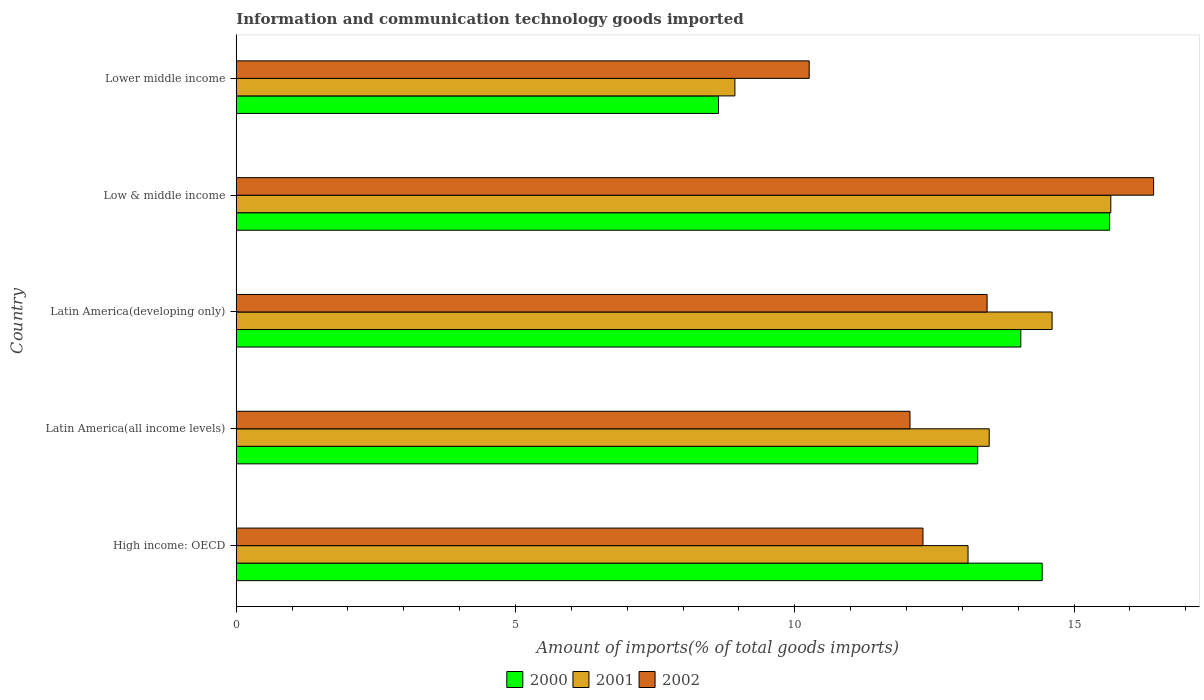How many groups of bars are there?
Ensure brevity in your answer.  5. Are the number of bars on each tick of the Y-axis equal?
Keep it short and to the point. Yes. How many bars are there on the 1st tick from the top?
Provide a succinct answer. 3. How many bars are there on the 1st tick from the bottom?
Ensure brevity in your answer.  3. What is the label of the 2nd group of bars from the top?
Your answer should be compact. Low & middle income. In how many cases, is the number of bars for a given country not equal to the number of legend labels?
Give a very brief answer. 0. What is the amount of goods imported in 2000 in Low & middle income?
Your response must be concise. 15.64. Across all countries, what is the maximum amount of goods imported in 2002?
Your response must be concise. 16.42. Across all countries, what is the minimum amount of goods imported in 2001?
Give a very brief answer. 8.93. In which country was the amount of goods imported in 2001 minimum?
Your answer should be compact. Lower middle income. What is the total amount of goods imported in 2001 in the graph?
Provide a short and direct response. 65.78. What is the difference between the amount of goods imported in 2001 in High income: OECD and that in Latin America(all income levels)?
Provide a short and direct response. -0.38. What is the difference between the amount of goods imported in 2002 in High income: OECD and the amount of goods imported in 2001 in Low & middle income?
Make the answer very short. -3.36. What is the average amount of goods imported in 2000 per country?
Provide a succinct answer. 13.2. What is the difference between the amount of goods imported in 2000 and amount of goods imported in 2002 in Lower middle income?
Make the answer very short. -1.62. What is the ratio of the amount of goods imported in 2002 in Low & middle income to that in Lower middle income?
Ensure brevity in your answer.  1.6. Is the amount of goods imported in 2001 in Low & middle income less than that in Lower middle income?
Ensure brevity in your answer.  No. What is the difference between the highest and the second highest amount of goods imported in 2001?
Provide a short and direct response. 1.05. What is the difference between the highest and the lowest amount of goods imported in 2001?
Make the answer very short. 6.73. In how many countries, is the amount of goods imported in 2001 greater than the average amount of goods imported in 2001 taken over all countries?
Offer a very short reply. 3. What does the 2nd bar from the bottom in Lower middle income represents?
Make the answer very short. 2001. Are all the bars in the graph horizontal?
Ensure brevity in your answer.  Yes. What is the difference between two consecutive major ticks on the X-axis?
Provide a succinct answer. 5. Are the values on the major ticks of X-axis written in scientific E-notation?
Your answer should be very brief. No. Does the graph contain grids?
Your response must be concise. No. How many legend labels are there?
Your answer should be very brief. 3. How are the legend labels stacked?
Your answer should be compact. Horizontal. What is the title of the graph?
Offer a very short reply. Information and communication technology goods imported. Does "1980" appear as one of the legend labels in the graph?
Your answer should be compact. No. What is the label or title of the X-axis?
Make the answer very short. Amount of imports(% of total goods imports). What is the label or title of the Y-axis?
Offer a terse response. Country. What is the Amount of imports(% of total goods imports) in 2000 in High income: OECD?
Ensure brevity in your answer.  14.43. What is the Amount of imports(% of total goods imports) of 2001 in High income: OECD?
Provide a short and direct response. 13.1. What is the Amount of imports(% of total goods imports) in 2002 in High income: OECD?
Provide a short and direct response. 12.3. What is the Amount of imports(% of total goods imports) of 2000 in Latin America(all income levels)?
Your answer should be compact. 13.27. What is the Amount of imports(% of total goods imports) in 2001 in Latin America(all income levels)?
Keep it short and to the point. 13.48. What is the Amount of imports(% of total goods imports) in 2002 in Latin America(all income levels)?
Keep it short and to the point. 12.06. What is the Amount of imports(% of total goods imports) in 2000 in Latin America(developing only)?
Your response must be concise. 14.05. What is the Amount of imports(% of total goods imports) in 2001 in Latin America(developing only)?
Provide a short and direct response. 14.61. What is the Amount of imports(% of total goods imports) in 2002 in Latin America(developing only)?
Offer a terse response. 13.44. What is the Amount of imports(% of total goods imports) in 2000 in Low & middle income?
Give a very brief answer. 15.64. What is the Amount of imports(% of total goods imports) in 2001 in Low & middle income?
Provide a short and direct response. 15.66. What is the Amount of imports(% of total goods imports) of 2002 in Low & middle income?
Your answer should be compact. 16.42. What is the Amount of imports(% of total goods imports) in 2000 in Lower middle income?
Ensure brevity in your answer.  8.63. What is the Amount of imports(% of total goods imports) of 2001 in Lower middle income?
Give a very brief answer. 8.93. What is the Amount of imports(% of total goods imports) in 2002 in Lower middle income?
Your response must be concise. 10.26. Across all countries, what is the maximum Amount of imports(% of total goods imports) of 2000?
Ensure brevity in your answer.  15.64. Across all countries, what is the maximum Amount of imports(% of total goods imports) in 2001?
Provide a short and direct response. 15.66. Across all countries, what is the maximum Amount of imports(% of total goods imports) in 2002?
Ensure brevity in your answer.  16.42. Across all countries, what is the minimum Amount of imports(% of total goods imports) of 2000?
Give a very brief answer. 8.63. Across all countries, what is the minimum Amount of imports(% of total goods imports) of 2001?
Provide a succinct answer. 8.93. Across all countries, what is the minimum Amount of imports(% of total goods imports) in 2002?
Offer a very short reply. 10.26. What is the total Amount of imports(% of total goods imports) of 2000 in the graph?
Offer a terse response. 66.02. What is the total Amount of imports(% of total goods imports) of 2001 in the graph?
Offer a terse response. 65.78. What is the total Amount of imports(% of total goods imports) of 2002 in the graph?
Offer a very short reply. 64.48. What is the difference between the Amount of imports(% of total goods imports) in 2000 in High income: OECD and that in Latin America(all income levels)?
Make the answer very short. 1.15. What is the difference between the Amount of imports(% of total goods imports) of 2001 in High income: OECD and that in Latin America(all income levels)?
Offer a very short reply. -0.38. What is the difference between the Amount of imports(% of total goods imports) of 2002 in High income: OECD and that in Latin America(all income levels)?
Make the answer very short. 0.23. What is the difference between the Amount of imports(% of total goods imports) of 2000 in High income: OECD and that in Latin America(developing only)?
Your answer should be very brief. 0.38. What is the difference between the Amount of imports(% of total goods imports) in 2001 in High income: OECD and that in Latin America(developing only)?
Ensure brevity in your answer.  -1.5. What is the difference between the Amount of imports(% of total goods imports) in 2002 in High income: OECD and that in Latin America(developing only)?
Offer a very short reply. -1.15. What is the difference between the Amount of imports(% of total goods imports) of 2000 in High income: OECD and that in Low & middle income?
Provide a succinct answer. -1.21. What is the difference between the Amount of imports(% of total goods imports) of 2001 in High income: OECD and that in Low & middle income?
Provide a short and direct response. -2.56. What is the difference between the Amount of imports(% of total goods imports) of 2002 in High income: OECD and that in Low & middle income?
Your answer should be very brief. -4.13. What is the difference between the Amount of imports(% of total goods imports) of 2000 in High income: OECD and that in Lower middle income?
Your response must be concise. 5.79. What is the difference between the Amount of imports(% of total goods imports) of 2001 in High income: OECD and that in Lower middle income?
Your answer should be very brief. 4.17. What is the difference between the Amount of imports(% of total goods imports) of 2002 in High income: OECD and that in Lower middle income?
Ensure brevity in your answer.  2.04. What is the difference between the Amount of imports(% of total goods imports) of 2000 in Latin America(all income levels) and that in Latin America(developing only)?
Provide a short and direct response. -0.77. What is the difference between the Amount of imports(% of total goods imports) in 2001 in Latin America(all income levels) and that in Latin America(developing only)?
Provide a short and direct response. -1.13. What is the difference between the Amount of imports(% of total goods imports) of 2002 in Latin America(all income levels) and that in Latin America(developing only)?
Your response must be concise. -1.38. What is the difference between the Amount of imports(% of total goods imports) in 2000 in Latin America(all income levels) and that in Low & middle income?
Your answer should be very brief. -2.36. What is the difference between the Amount of imports(% of total goods imports) of 2001 in Latin America(all income levels) and that in Low & middle income?
Offer a very short reply. -2.18. What is the difference between the Amount of imports(% of total goods imports) in 2002 in Latin America(all income levels) and that in Low & middle income?
Ensure brevity in your answer.  -4.36. What is the difference between the Amount of imports(% of total goods imports) in 2000 in Latin America(all income levels) and that in Lower middle income?
Keep it short and to the point. 4.64. What is the difference between the Amount of imports(% of total goods imports) of 2001 in Latin America(all income levels) and that in Lower middle income?
Your answer should be compact. 4.55. What is the difference between the Amount of imports(% of total goods imports) of 2002 in Latin America(all income levels) and that in Lower middle income?
Ensure brevity in your answer.  1.8. What is the difference between the Amount of imports(% of total goods imports) of 2000 in Latin America(developing only) and that in Low & middle income?
Make the answer very short. -1.59. What is the difference between the Amount of imports(% of total goods imports) in 2001 in Latin America(developing only) and that in Low & middle income?
Offer a terse response. -1.05. What is the difference between the Amount of imports(% of total goods imports) in 2002 in Latin America(developing only) and that in Low & middle income?
Offer a very short reply. -2.98. What is the difference between the Amount of imports(% of total goods imports) of 2000 in Latin America(developing only) and that in Lower middle income?
Offer a terse response. 5.41. What is the difference between the Amount of imports(% of total goods imports) in 2001 in Latin America(developing only) and that in Lower middle income?
Give a very brief answer. 5.68. What is the difference between the Amount of imports(% of total goods imports) in 2002 in Latin America(developing only) and that in Lower middle income?
Keep it short and to the point. 3.19. What is the difference between the Amount of imports(% of total goods imports) of 2000 in Low & middle income and that in Lower middle income?
Provide a short and direct response. 7. What is the difference between the Amount of imports(% of total goods imports) in 2001 in Low & middle income and that in Lower middle income?
Offer a terse response. 6.73. What is the difference between the Amount of imports(% of total goods imports) of 2002 in Low & middle income and that in Lower middle income?
Offer a terse response. 6.17. What is the difference between the Amount of imports(% of total goods imports) of 2000 in High income: OECD and the Amount of imports(% of total goods imports) of 2001 in Latin America(all income levels)?
Make the answer very short. 0.95. What is the difference between the Amount of imports(% of total goods imports) in 2000 in High income: OECD and the Amount of imports(% of total goods imports) in 2002 in Latin America(all income levels)?
Your answer should be very brief. 2.37. What is the difference between the Amount of imports(% of total goods imports) in 2001 in High income: OECD and the Amount of imports(% of total goods imports) in 2002 in Latin America(all income levels)?
Keep it short and to the point. 1.04. What is the difference between the Amount of imports(% of total goods imports) in 2000 in High income: OECD and the Amount of imports(% of total goods imports) in 2001 in Latin America(developing only)?
Ensure brevity in your answer.  -0.18. What is the difference between the Amount of imports(% of total goods imports) of 2000 in High income: OECD and the Amount of imports(% of total goods imports) of 2002 in Latin America(developing only)?
Your response must be concise. 0.99. What is the difference between the Amount of imports(% of total goods imports) in 2001 in High income: OECD and the Amount of imports(% of total goods imports) in 2002 in Latin America(developing only)?
Your response must be concise. -0.34. What is the difference between the Amount of imports(% of total goods imports) of 2000 in High income: OECD and the Amount of imports(% of total goods imports) of 2001 in Low & middle income?
Offer a very short reply. -1.23. What is the difference between the Amount of imports(% of total goods imports) of 2000 in High income: OECD and the Amount of imports(% of total goods imports) of 2002 in Low & middle income?
Make the answer very short. -2. What is the difference between the Amount of imports(% of total goods imports) in 2001 in High income: OECD and the Amount of imports(% of total goods imports) in 2002 in Low & middle income?
Provide a short and direct response. -3.32. What is the difference between the Amount of imports(% of total goods imports) in 2000 in High income: OECD and the Amount of imports(% of total goods imports) in 2001 in Lower middle income?
Your response must be concise. 5.5. What is the difference between the Amount of imports(% of total goods imports) in 2000 in High income: OECD and the Amount of imports(% of total goods imports) in 2002 in Lower middle income?
Provide a short and direct response. 4.17. What is the difference between the Amount of imports(% of total goods imports) of 2001 in High income: OECD and the Amount of imports(% of total goods imports) of 2002 in Lower middle income?
Offer a very short reply. 2.84. What is the difference between the Amount of imports(% of total goods imports) of 2000 in Latin America(all income levels) and the Amount of imports(% of total goods imports) of 2001 in Latin America(developing only)?
Make the answer very short. -1.33. What is the difference between the Amount of imports(% of total goods imports) in 2000 in Latin America(all income levels) and the Amount of imports(% of total goods imports) in 2002 in Latin America(developing only)?
Your answer should be compact. -0.17. What is the difference between the Amount of imports(% of total goods imports) in 2001 in Latin America(all income levels) and the Amount of imports(% of total goods imports) in 2002 in Latin America(developing only)?
Make the answer very short. 0.04. What is the difference between the Amount of imports(% of total goods imports) of 2000 in Latin America(all income levels) and the Amount of imports(% of total goods imports) of 2001 in Low & middle income?
Ensure brevity in your answer.  -2.38. What is the difference between the Amount of imports(% of total goods imports) of 2000 in Latin America(all income levels) and the Amount of imports(% of total goods imports) of 2002 in Low & middle income?
Your response must be concise. -3.15. What is the difference between the Amount of imports(% of total goods imports) of 2001 in Latin America(all income levels) and the Amount of imports(% of total goods imports) of 2002 in Low & middle income?
Your response must be concise. -2.94. What is the difference between the Amount of imports(% of total goods imports) in 2000 in Latin America(all income levels) and the Amount of imports(% of total goods imports) in 2001 in Lower middle income?
Make the answer very short. 4.35. What is the difference between the Amount of imports(% of total goods imports) of 2000 in Latin America(all income levels) and the Amount of imports(% of total goods imports) of 2002 in Lower middle income?
Ensure brevity in your answer.  3.02. What is the difference between the Amount of imports(% of total goods imports) in 2001 in Latin America(all income levels) and the Amount of imports(% of total goods imports) in 2002 in Lower middle income?
Ensure brevity in your answer.  3.22. What is the difference between the Amount of imports(% of total goods imports) of 2000 in Latin America(developing only) and the Amount of imports(% of total goods imports) of 2001 in Low & middle income?
Give a very brief answer. -1.61. What is the difference between the Amount of imports(% of total goods imports) of 2000 in Latin America(developing only) and the Amount of imports(% of total goods imports) of 2002 in Low & middle income?
Make the answer very short. -2.38. What is the difference between the Amount of imports(% of total goods imports) of 2001 in Latin America(developing only) and the Amount of imports(% of total goods imports) of 2002 in Low & middle income?
Provide a short and direct response. -1.82. What is the difference between the Amount of imports(% of total goods imports) in 2000 in Latin America(developing only) and the Amount of imports(% of total goods imports) in 2001 in Lower middle income?
Ensure brevity in your answer.  5.12. What is the difference between the Amount of imports(% of total goods imports) in 2000 in Latin America(developing only) and the Amount of imports(% of total goods imports) in 2002 in Lower middle income?
Provide a short and direct response. 3.79. What is the difference between the Amount of imports(% of total goods imports) in 2001 in Latin America(developing only) and the Amount of imports(% of total goods imports) in 2002 in Lower middle income?
Your answer should be very brief. 4.35. What is the difference between the Amount of imports(% of total goods imports) in 2000 in Low & middle income and the Amount of imports(% of total goods imports) in 2001 in Lower middle income?
Provide a short and direct response. 6.71. What is the difference between the Amount of imports(% of total goods imports) of 2000 in Low & middle income and the Amount of imports(% of total goods imports) of 2002 in Lower middle income?
Provide a succinct answer. 5.38. What is the difference between the Amount of imports(% of total goods imports) in 2001 in Low & middle income and the Amount of imports(% of total goods imports) in 2002 in Lower middle income?
Offer a terse response. 5.4. What is the average Amount of imports(% of total goods imports) of 2000 per country?
Ensure brevity in your answer.  13.2. What is the average Amount of imports(% of total goods imports) in 2001 per country?
Offer a terse response. 13.15. What is the average Amount of imports(% of total goods imports) in 2002 per country?
Your answer should be very brief. 12.9. What is the difference between the Amount of imports(% of total goods imports) of 2000 and Amount of imports(% of total goods imports) of 2001 in High income: OECD?
Your answer should be very brief. 1.33. What is the difference between the Amount of imports(% of total goods imports) of 2000 and Amount of imports(% of total goods imports) of 2002 in High income: OECD?
Your response must be concise. 2.13. What is the difference between the Amount of imports(% of total goods imports) in 2001 and Amount of imports(% of total goods imports) in 2002 in High income: OECD?
Your answer should be very brief. 0.81. What is the difference between the Amount of imports(% of total goods imports) in 2000 and Amount of imports(% of total goods imports) in 2001 in Latin America(all income levels)?
Your answer should be compact. -0.21. What is the difference between the Amount of imports(% of total goods imports) of 2000 and Amount of imports(% of total goods imports) of 2002 in Latin America(all income levels)?
Keep it short and to the point. 1.21. What is the difference between the Amount of imports(% of total goods imports) of 2001 and Amount of imports(% of total goods imports) of 2002 in Latin America(all income levels)?
Your answer should be compact. 1.42. What is the difference between the Amount of imports(% of total goods imports) in 2000 and Amount of imports(% of total goods imports) in 2001 in Latin America(developing only)?
Offer a very short reply. -0.56. What is the difference between the Amount of imports(% of total goods imports) of 2000 and Amount of imports(% of total goods imports) of 2002 in Latin America(developing only)?
Provide a short and direct response. 0.6. What is the difference between the Amount of imports(% of total goods imports) in 2001 and Amount of imports(% of total goods imports) in 2002 in Latin America(developing only)?
Provide a short and direct response. 1.16. What is the difference between the Amount of imports(% of total goods imports) of 2000 and Amount of imports(% of total goods imports) of 2001 in Low & middle income?
Provide a succinct answer. -0.02. What is the difference between the Amount of imports(% of total goods imports) in 2000 and Amount of imports(% of total goods imports) in 2002 in Low & middle income?
Offer a very short reply. -0.79. What is the difference between the Amount of imports(% of total goods imports) in 2001 and Amount of imports(% of total goods imports) in 2002 in Low & middle income?
Make the answer very short. -0.77. What is the difference between the Amount of imports(% of total goods imports) of 2000 and Amount of imports(% of total goods imports) of 2001 in Lower middle income?
Make the answer very short. -0.29. What is the difference between the Amount of imports(% of total goods imports) of 2000 and Amount of imports(% of total goods imports) of 2002 in Lower middle income?
Provide a succinct answer. -1.62. What is the difference between the Amount of imports(% of total goods imports) of 2001 and Amount of imports(% of total goods imports) of 2002 in Lower middle income?
Your response must be concise. -1.33. What is the ratio of the Amount of imports(% of total goods imports) in 2000 in High income: OECD to that in Latin America(all income levels)?
Your answer should be compact. 1.09. What is the ratio of the Amount of imports(% of total goods imports) of 2001 in High income: OECD to that in Latin America(all income levels)?
Offer a very short reply. 0.97. What is the ratio of the Amount of imports(% of total goods imports) of 2002 in High income: OECD to that in Latin America(all income levels)?
Make the answer very short. 1.02. What is the ratio of the Amount of imports(% of total goods imports) in 2000 in High income: OECD to that in Latin America(developing only)?
Your answer should be very brief. 1.03. What is the ratio of the Amount of imports(% of total goods imports) in 2001 in High income: OECD to that in Latin America(developing only)?
Offer a terse response. 0.9. What is the ratio of the Amount of imports(% of total goods imports) in 2002 in High income: OECD to that in Latin America(developing only)?
Give a very brief answer. 0.91. What is the ratio of the Amount of imports(% of total goods imports) in 2000 in High income: OECD to that in Low & middle income?
Your response must be concise. 0.92. What is the ratio of the Amount of imports(% of total goods imports) in 2001 in High income: OECD to that in Low & middle income?
Provide a short and direct response. 0.84. What is the ratio of the Amount of imports(% of total goods imports) in 2002 in High income: OECD to that in Low & middle income?
Your answer should be compact. 0.75. What is the ratio of the Amount of imports(% of total goods imports) of 2000 in High income: OECD to that in Lower middle income?
Make the answer very short. 1.67. What is the ratio of the Amount of imports(% of total goods imports) in 2001 in High income: OECD to that in Lower middle income?
Ensure brevity in your answer.  1.47. What is the ratio of the Amount of imports(% of total goods imports) in 2002 in High income: OECD to that in Lower middle income?
Give a very brief answer. 1.2. What is the ratio of the Amount of imports(% of total goods imports) of 2000 in Latin America(all income levels) to that in Latin America(developing only)?
Your response must be concise. 0.95. What is the ratio of the Amount of imports(% of total goods imports) in 2001 in Latin America(all income levels) to that in Latin America(developing only)?
Provide a short and direct response. 0.92. What is the ratio of the Amount of imports(% of total goods imports) in 2002 in Latin America(all income levels) to that in Latin America(developing only)?
Your answer should be compact. 0.9. What is the ratio of the Amount of imports(% of total goods imports) in 2000 in Latin America(all income levels) to that in Low & middle income?
Provide a short and direct response. 0.85. What is the ratio of the Amount of imports(% of total goods imports) of 2001 in Latin America(all income levels) to that in Low & middle income?
Provide a short and direct response. 0.86. What is the ratio of the Amount of imports(% of total goods imports) of 2002 in Latin America(all income levels) to that in Low & middle income?
Offer a very short reply. 0.73. What is the ratio of the Amount of imports(% of total goods imports) of 2000 in Latin America(all income levels) to that in Lower middle income?
Your answer should be compact. 1.54. What is the ratio of the Amount of imports(% of total goods imports) in 2001 in Latin America(all income levels) to that in Lower middle income?
Your answer should be very brief. 1.51. What is the ratio of the Amount of imports(% of total goods imports) in 2002 in Latin America(all income levels) to that in Lower middle income?
Your response must be concise. 1.18. What is the ratio of the Amount of imports(% of total goods imports) in 2000 in Latin America(developing only) to that in Low & middle income?
Provide a succinct answer. 0.9. What is the ratio of the Amount of imports(% of total goods imports) in 2001 in Latin America(developing only) to that in Low & middle income?
Make the answer very short. 0.93. What is the ratio of the Amount of imports(% of total goods imports) of 2002 in Latin America(developing only) to that in Low & middle income?
Provide a succinct answer. 0.82. What is the ratio of the Amount of imports(% of total goods imports) of 2000 in Latin America(developing only) to that in Lower middle income?
Your response must be concise. 1.63. What is the ratio of the Amount of imports(% of total goods imports) in 2001 in Latin America(developing only) to that in Lower middle income?
Your answer should be compact. 1.64. What is the ratio of the Amount of imports(% of total goods imports) in 2002 in Latin America(developing only) to that in Lower middle income?
Offer a terse response. 1.31. What is the ratio of the Amount of imports(% of total goods imports) of 2000 in Low & middle income to that in Lower middle income?
Provide a succinct answer. 1.81. What is the ratio of the Amount of imports(% of total goods imports) of 2001 in Low & middle income to that in Lower middle income?
Provide a succinct answer. 1.75. What is the ratio of the Amount of imports(% of total goods imports) in 2002 in Low & middle income to that in Lower middle income?
Offer a terse response. 1.6. What is the difference between the highest and the second highest Amount of imports(% of total goods imports) of 2000?
Make the answer very short. 1.21. What is the difference between the highest and the second highest Amount of imports(% of total goods imports) of 2001?
Offer a terse response. 1.05. What is the difference between the highest and the second highest Amount of imports(% of total goods imports) of 2002?
Provide a succinct answer. 2.98. What is the difference between the highest and the lowest Amount of imports(% of total goods imports) of 2000?
Your response must be concise. 7. What is the difference between the highest and the lowest Amount of imports(% of total goods imports) in 2001?
Keep it short and to the point. 6.73. What is the difference between the highest and the lowest Amount of imports(% of total goods imports) of 2002?
Your answer should be compact. 6.17. 